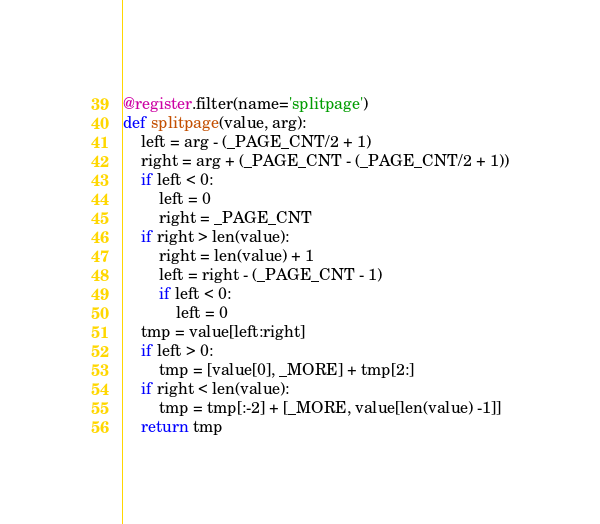Convert code to text. <code><loc_0><loc_0><loc_500><loc_500><_Python_>@register.filter(name='splitpage')
def splitpage(value, arg):
    left = arg - (_PAGE_CNT/2 + 1)
    right = arg + (_PAGE_CNT - (_PAGE_CNT/2 + 1))
    if left < 0:
        left = 0
        right = _PAGE_CNT
    if right > len(value):
        right = len(value) + 1
        left = right - (_PAGE_CNT - 1)
        if left < 0:
            left = 0
    tmp = value[left:right]
    if left > 0:
        tmp = [value[0], _MORE] + tmp[2:]
    if right < len(value):
        tmp = tmp[:-2] + [_MORE, value[len(value) -1]]
    return tmp
</code> 